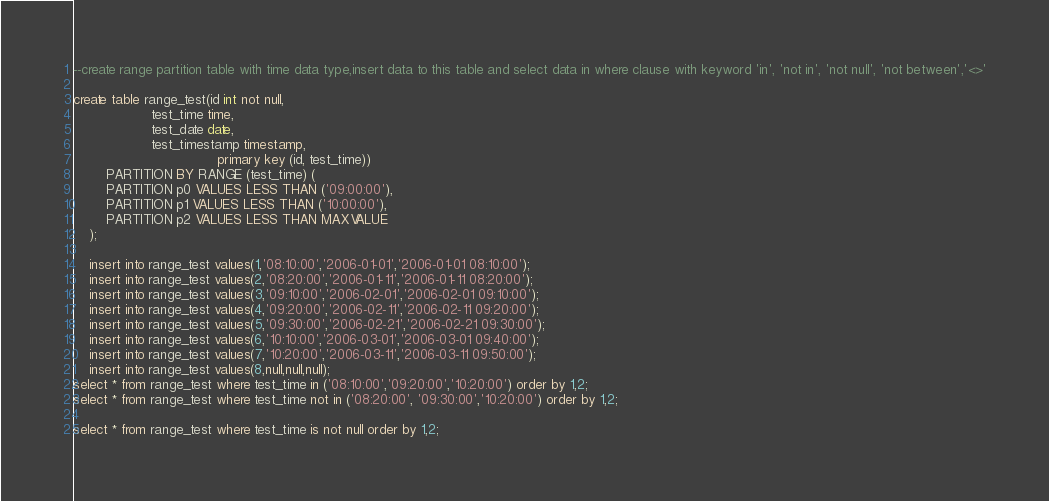<code> <loc_0><loc_0><loc_500><loc_500><_SQL_>--create range partition table with time data type,insert data to this table and select data in where clause with keyword 'in', 'not in', 'not null', 'not between','<>'

create table range_test(id int not null,	
				   test_time time,
				   test_date date,
				   test_timestamp timestamp,
                                   primary key (id, test_time))
		PARTITION BY RANGE (test_time) (
		PARTITION p0 VALUES LESS THAN ('09:00:00'),
		PARTITION p1 VALUES LESS THAN ('10:00:00'),
		PARTITION p2 VALUES LESS THAN MAXVALUE
	);

	insert into range_test values(1,'08:10:00','2006-01-01','2006-01-01 08:10:00');
	insert into range_test values(2,'08:20:00','2006-01-11','2006-01-11 08:20:00');
	insert into range_test values(3,'09:10:00','2006-02-01','2006-02-01 09:10:00');
	insert into range_test values(4,'09:20:00','2006-02-11','2006-02-11 09:20:00');
	insert into range_test values(5,'09:30:00','2006-02-21','2006-02-21 09:30:00');
	insert into range_test values(6,'10:10:00','2006-03-01','2006-03-01 09:40:00');
	insert into range_test values(7,'10:20:00','2006-03-11','2006-03-11 09:50:00');
	insert into range_test values(8,null,null,null);
select * from range_test where test_time in ('08:10:00','09:20:00','10:20:00') order by 1,2;
select * from range_test where test_time not in ('08:20:00', '09:30:00','10:20:00') order by 1,2;

select * from range_test where test_time is not null order by 1,2;</code> 